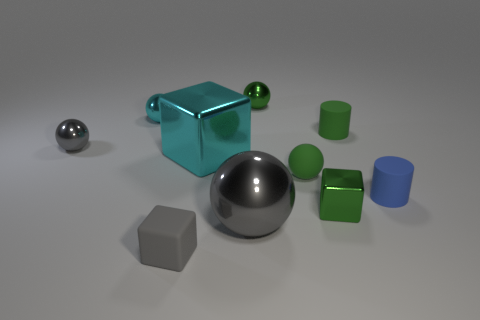Subtract all small matte balls. How many balls are left? 4 Subtract all cyan cylinders. How many green balls are left? 2 Subtract all green spheres. How many spheres are left? 3 Subtract 1 cubes. How many cubes are left? 2 Subtract all cylinders. How many objects are left? 8 Subtract all brown balls. Subtract all red cylinders. How many balls are left? 5 Subtract 0 yellow balls. How many objects are left? 10 Subtract all metal things. Subtract all cyan spheres. How many objects are left? 3 Add 1 cyan spheres. How many cyan spheres are left? 2 Add 5 metal spheres. How many metal spheres exist? 9 